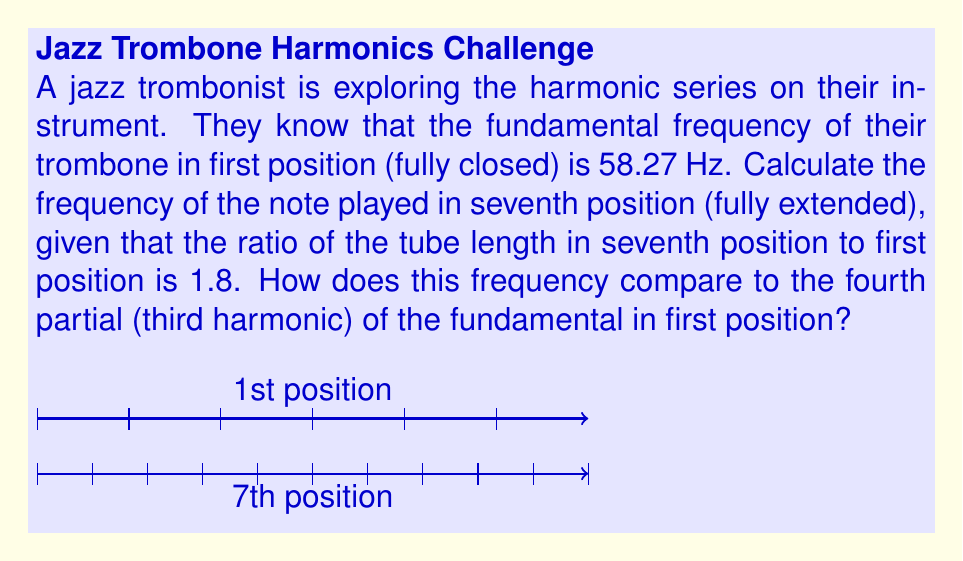Help me with this question. Let's approach this step-by-step:

1) The frequency of a note is inversely proportional to the length of the vibrating air column. We can express this relationship as:

   $$f_1 L_1 = f_7 L_7$$

   where $f_1$ and $L_1$ are the frequency and length in first position, and $f_7$ and $L_7$ are the frequency and length in seventh position.

2) We're given that $L_7 = 1.8L_1$ and $f_1 = 58.27$ Hz. Let's substitute these into our equation:

   $$58.27 \cdot L_1 = f_7 \cdot 1.8L_1$$

3) The $L_1$ cancels out on both sides:

   $$58.27 = 1.8f_7$$

4) Solving for $f_7$:

   $$f_7 = \frac{58.27}{1.8} = 32.37$ Hz$$

5) Now, let's calculate the fourth partial (third harmonic) of the fundamental in first position. The frequency of the nth harmonic is n times the fundamental frequency:

   $$f_4 = 4 \cdot 58.27 = 233.08$ Hz$$

6) To compare these frequencies, we can calculate their ratio:

   $$\text{Ratio} = \frac{233.08}{32.37} \approx 7.20$$

This means the fourth partial in first position is about 7.20 times higher in frequency than the fundamental in seventh position.
Answer: $f_7 = 32.37$ Hz; Ratio to 4th partial ≈ 7.20 